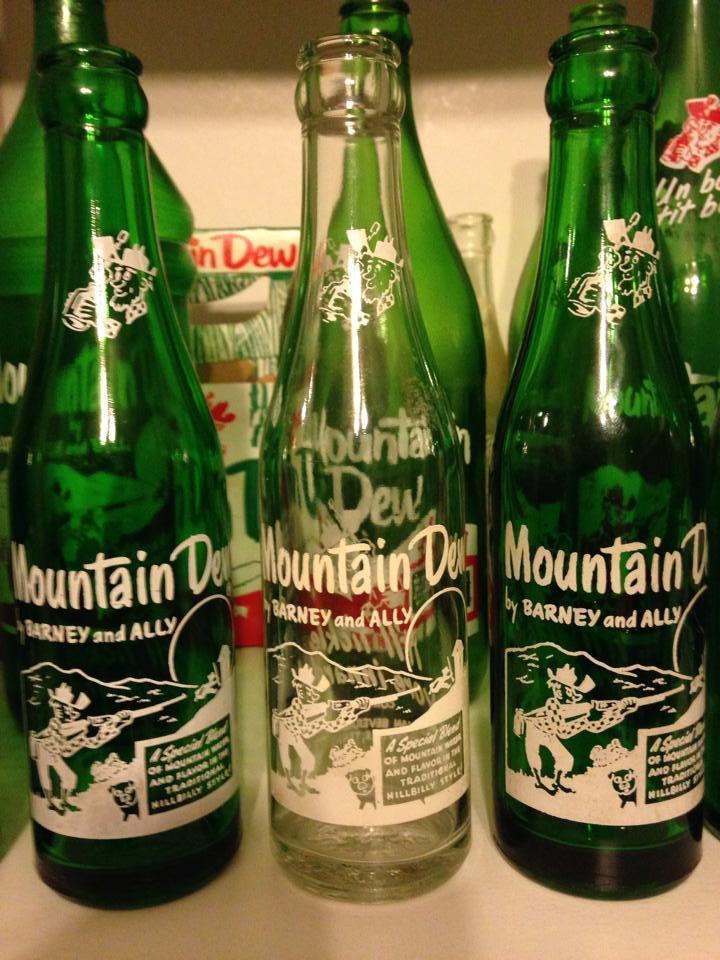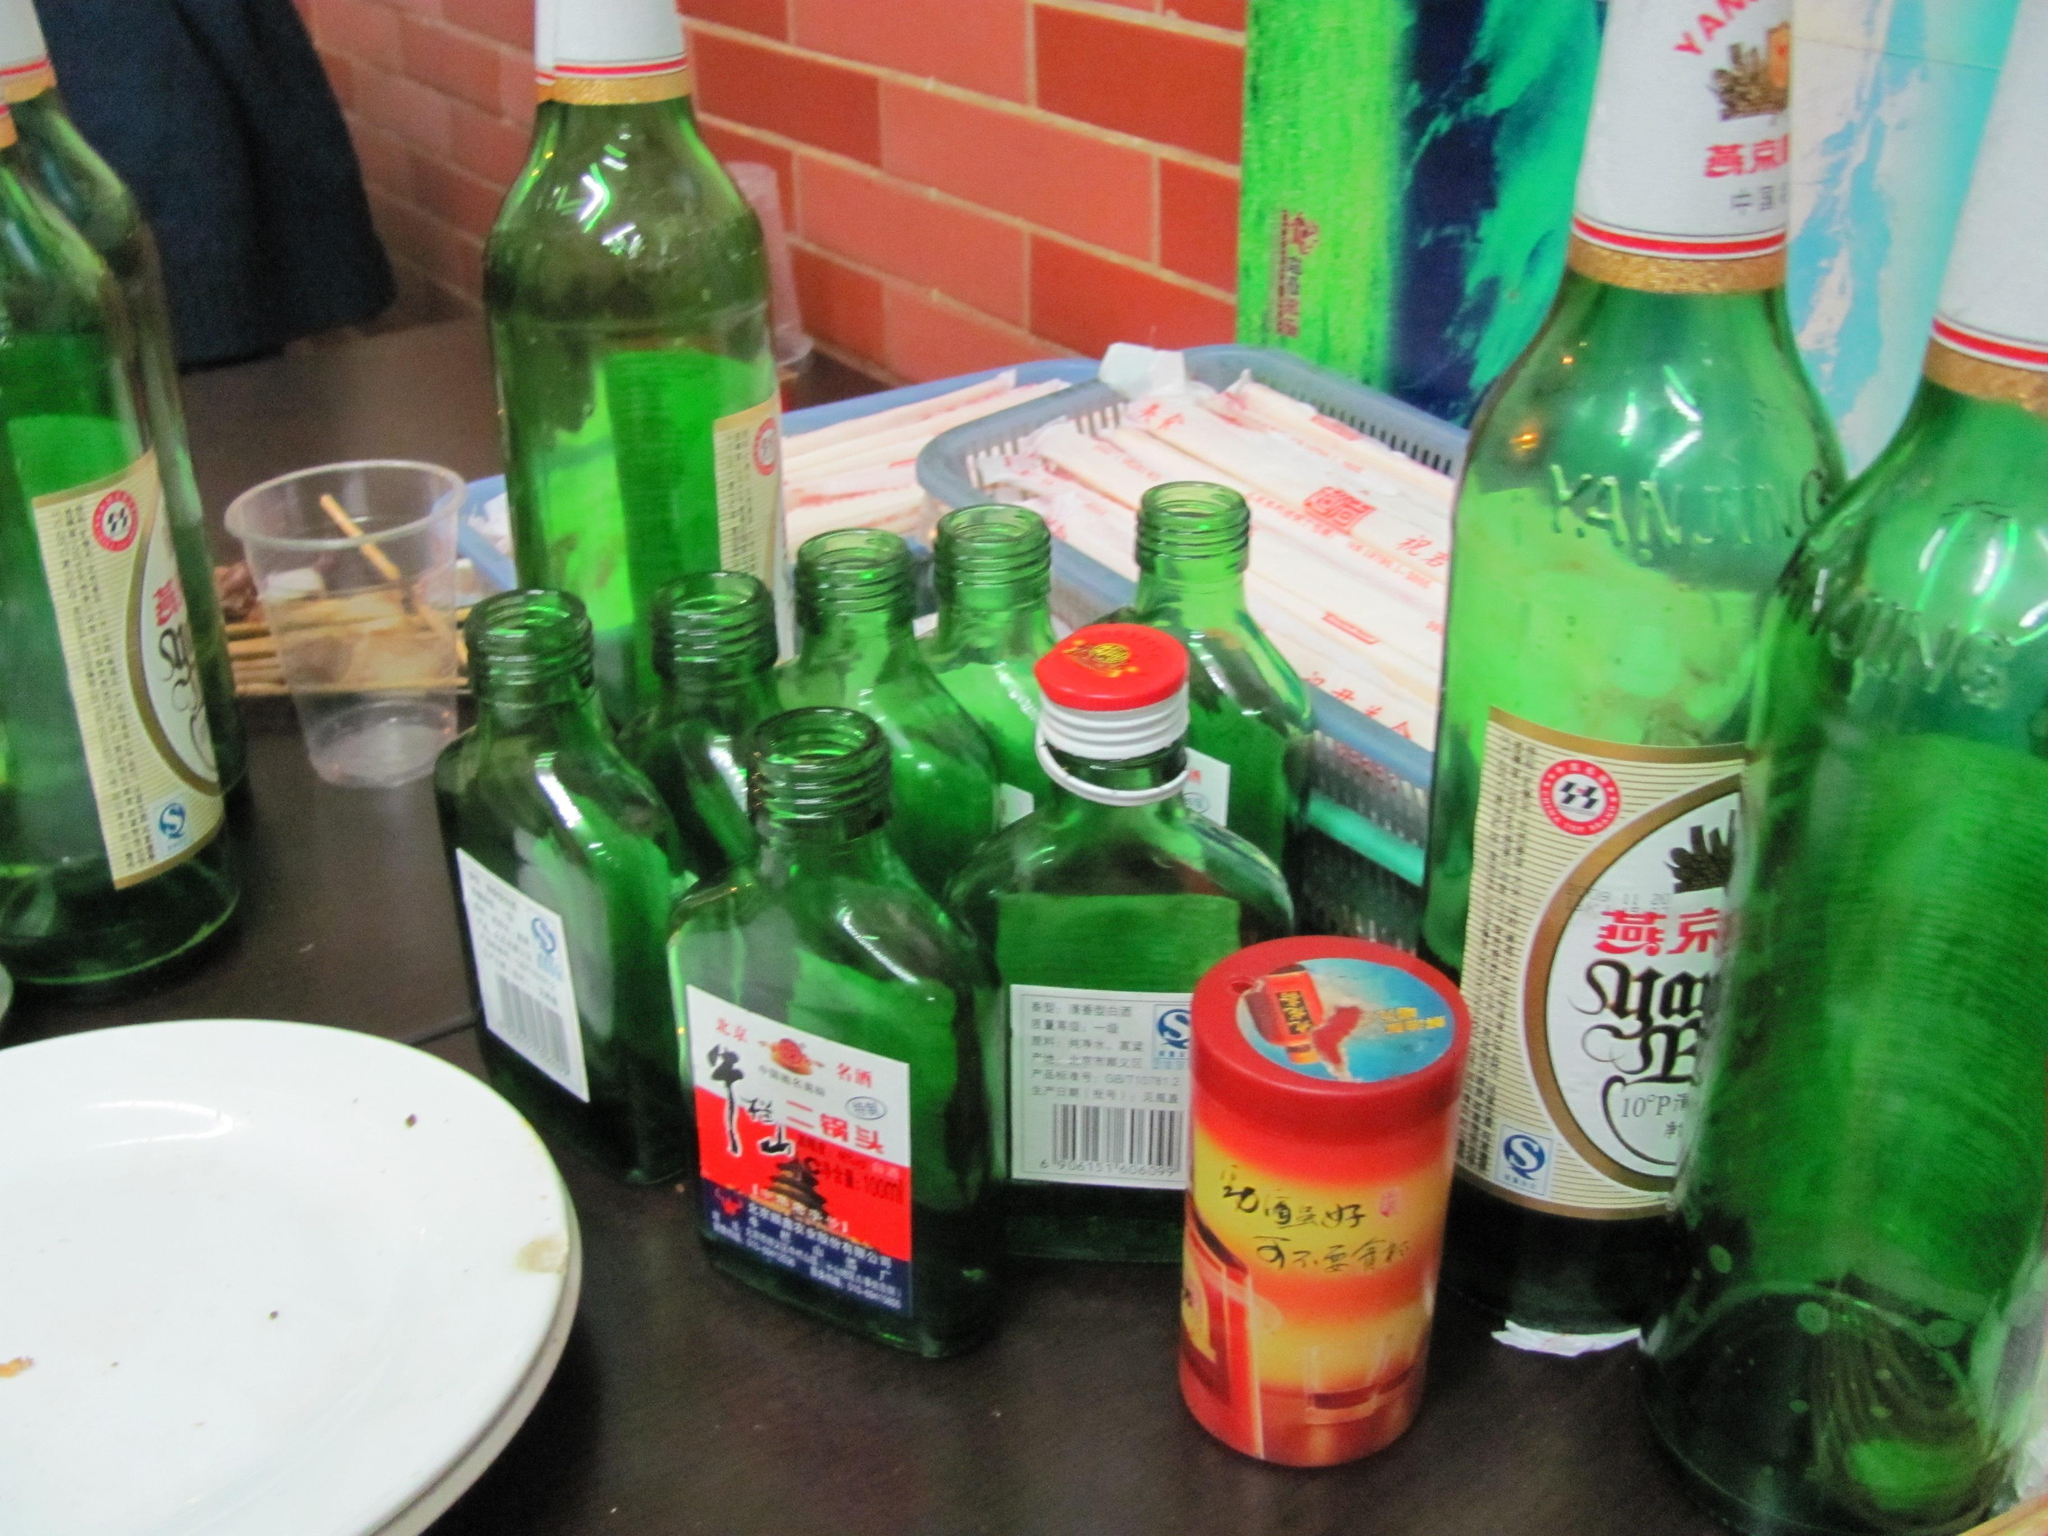The first image is the image on the left, the second image is the image on the right. Given the left and right images, does the statement "Two green bottles are sitting near some ice." hold true? Answer yes or no. No. The first image is the image on the left, the second image is the image on the right. For the images displayed, is the sentence "Neither individual image includes more than two bottles." factually correct? Answer yes or no. No. 